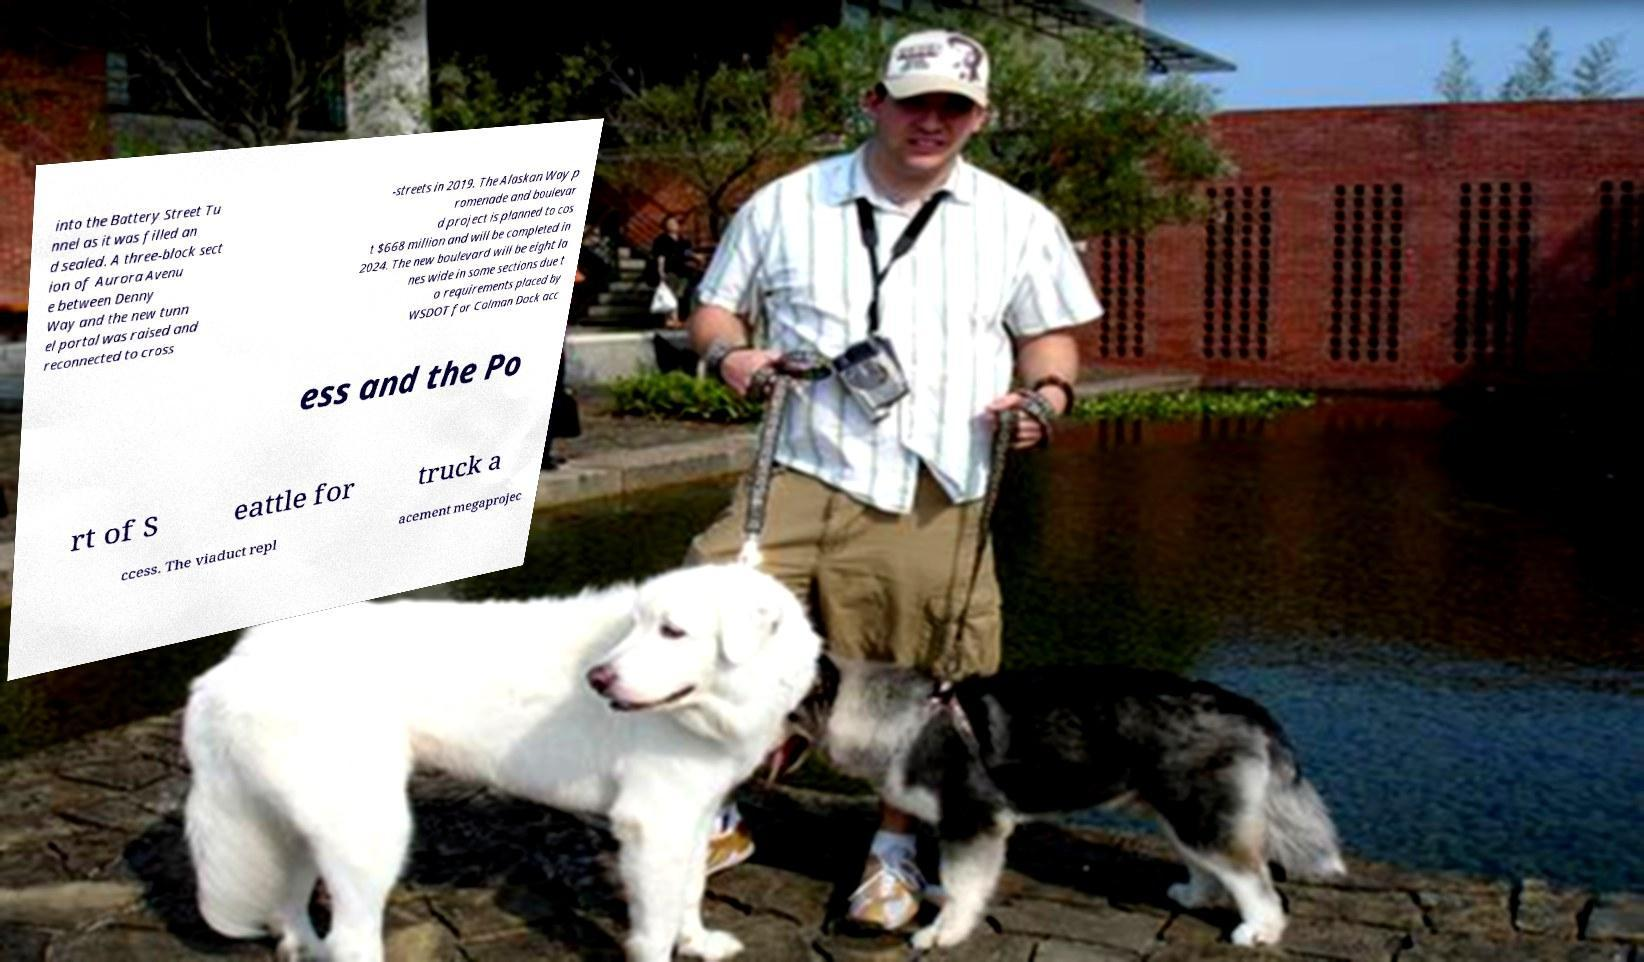Please read and relay the text visible in this image. What does it say? into the Battery Street Tu nnel as it was filled an d sealed. A three-block sect ion of Aurora Avenu e between Denny Way and the new tunn el portal was raised and reconnected to cross -streets in 2019. The Alaskan Way p romenade and boulevar d project is planned to cos t $668 million and will be completed in 2024. The new boulevard will be eight la nes wide in some sections due t o requirements placed by WSDOT for Colman Dock acc ess and the Po rt of S eattle for truck a ccess. The viaduct repl acement megaprojec 